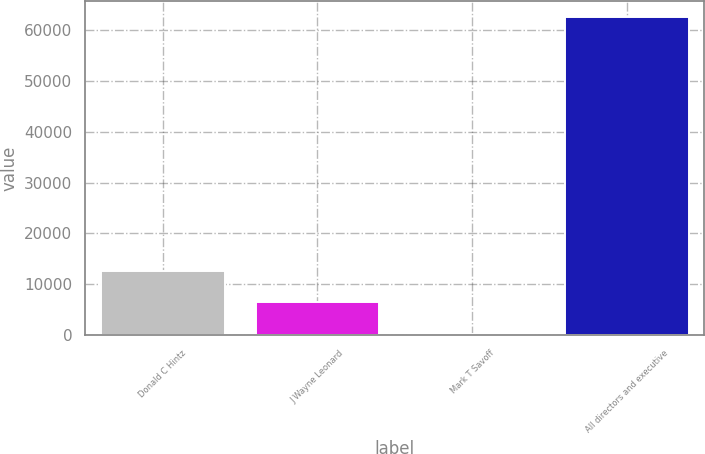<chart> <loc_0><loc_0><loc_500><loc_500><bar_chart><fcel>Donald C Hintz<fcel>J Wayne Leonard<fcel>Mark T Savoff<fcel>All directors and executive<nl><fcel>12719<fcel>6491<fcel>263<fcel>62543<nl></chart> 